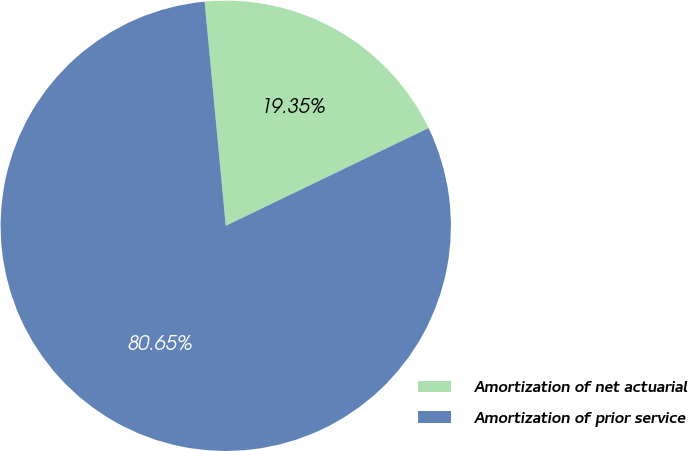<chart> <loc_0><loc_0><loc_500><loc_500><pie_chart><fcel>Amortization of net actuarial<fcel>Amortization of prior service<nl><fcel>19.35%<fcel>80.65%<nl></chart> 